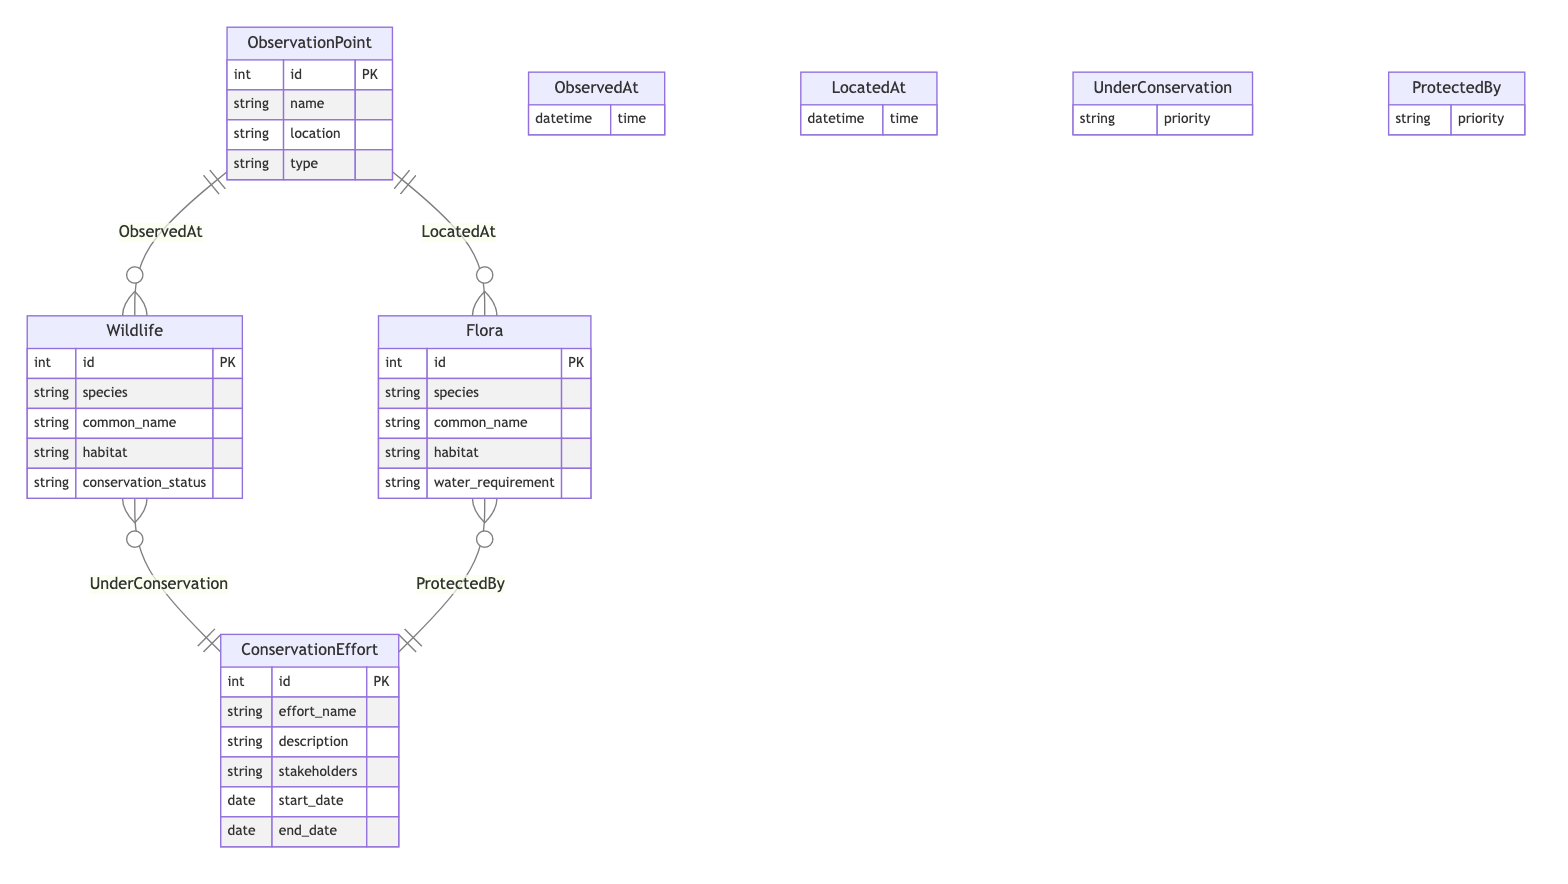What attributes does the ObservationPoint entity have? The ObservationPoint entity contains the attributes: id, name, location, and type.
Answer: id, name, location, type How many entities are there in the diagram? There are four entities in the diagram: ObservationPoint, Wildlife, Flora, and ConservationEffort.
Answer: 4 What is the relationship between Wildlife and ObservationPoint? The relationship between Wildlife and ObservationPoint is labeled "ObservedAt."
Answer: ObservedAt What attribute is associated with the relationship "UnderConservation"? The attribute associated with the "UnderConservation" relationship is priority.
Answer: priority Which ConservationEffort can protect Flora? Any ConservationEffort associated with the relationship "ProtectedBy" can protect Flora.
Answer: ProtectedBy What type of interaction does the relationship "LocatedAt" represent? The "LocatedAt" relationship represents the interaction where Fluora is observed at specific ObservationPoints.
Answer: Flora at ObservationPoints How many attributes does the Wildlife entity contain? The Wildlife entity contains five attributes: id, species, common_name, habitat, and conservation_status.
Answer: 5 Which entity is linked to the ConservationEffort with the "UnderConservation" relationship? The Wildlife entity is linked to the ConservationEffort through the "UnderConservation" relationship.
Answer: Wildlife What time information is captured in both the ObservedAt and LocatedAt relationships? Both the ObservedAt and LocatedAt relationships capture a datetime attribute for the time of interaction.
Answer: time 